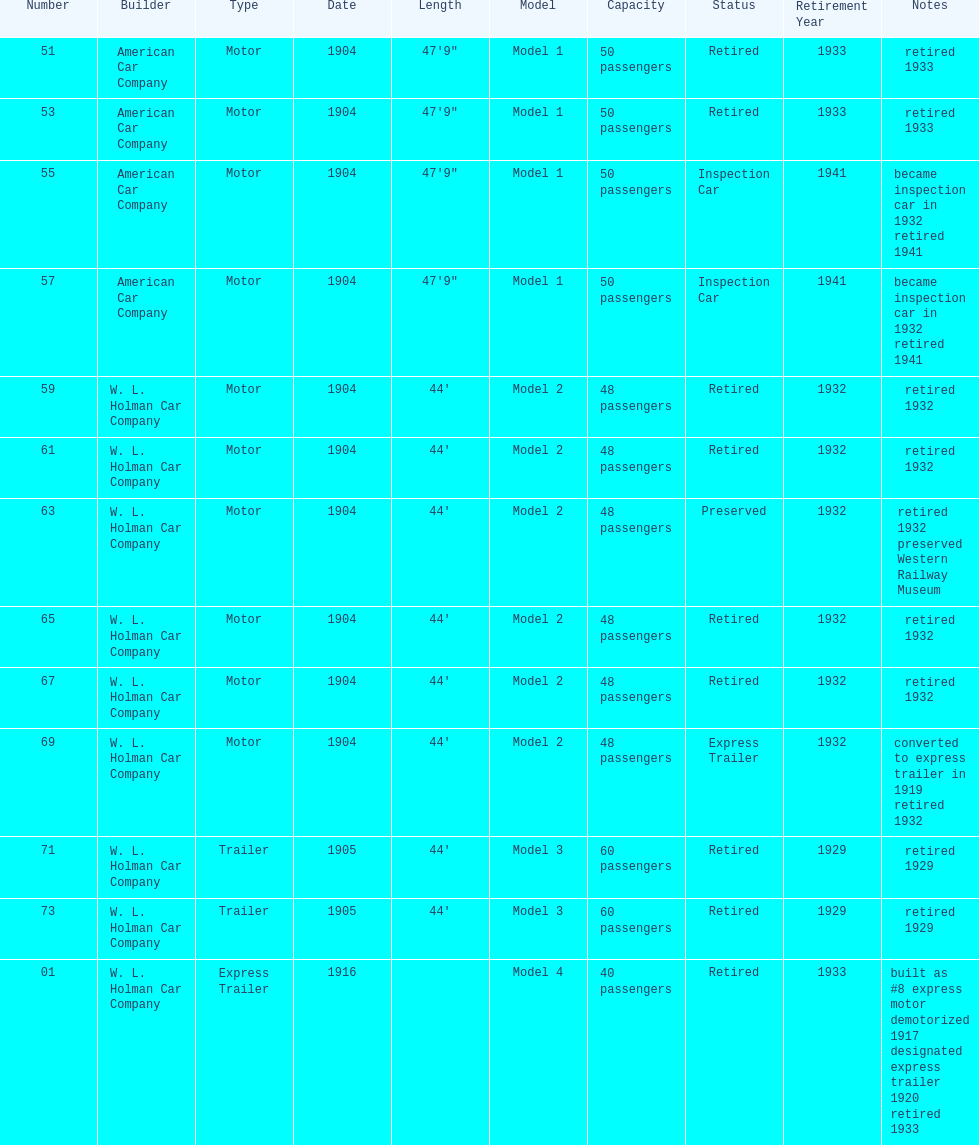What was the total number of cars listed? 13. 